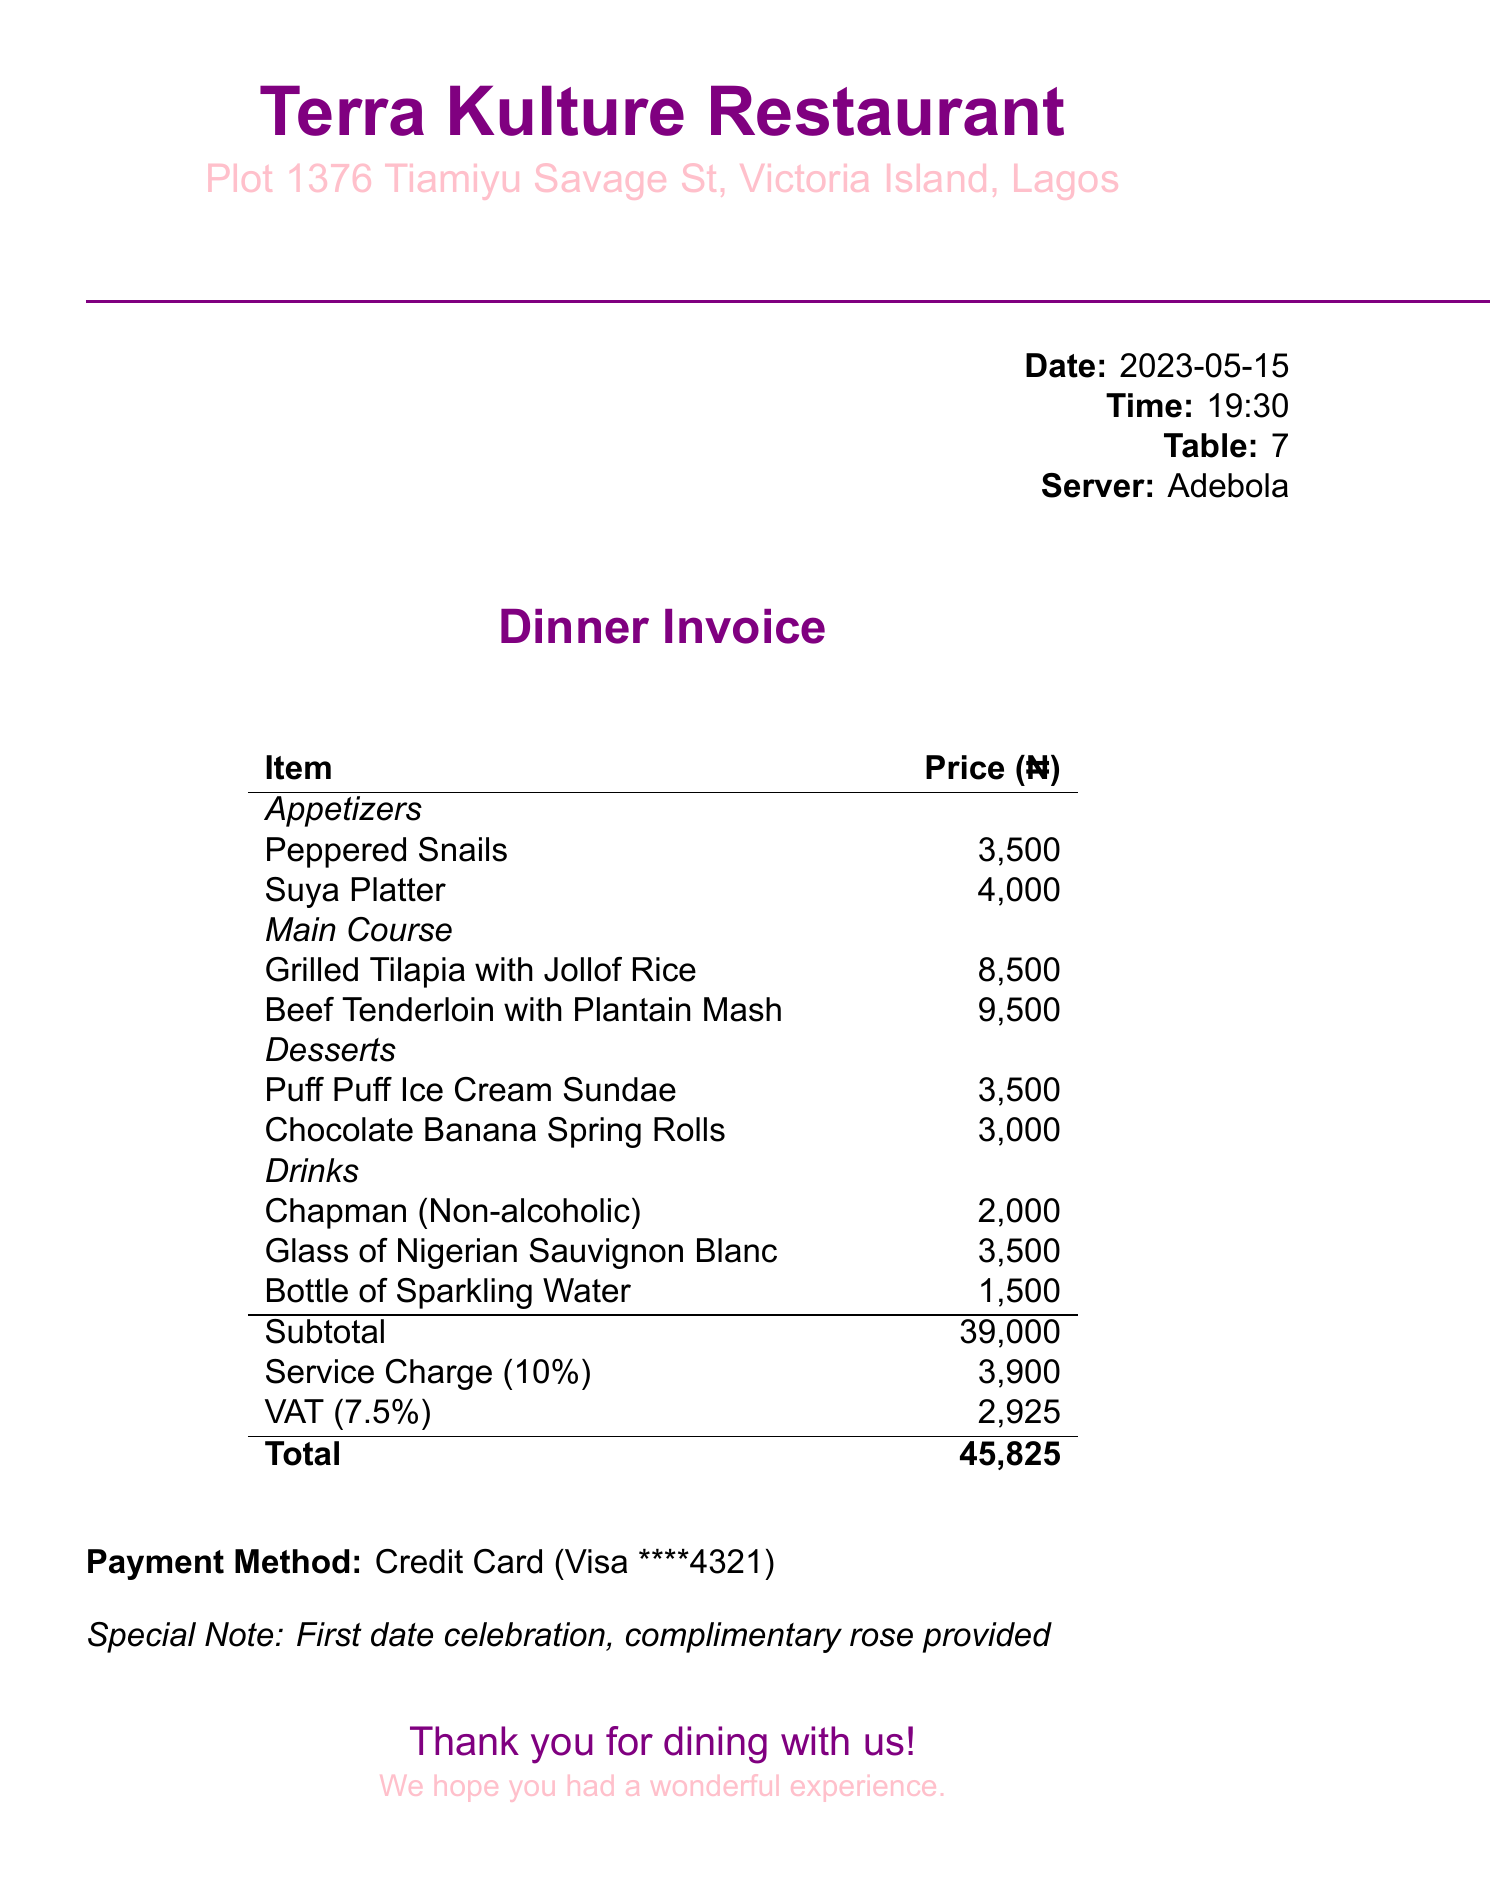what is the name of the restaurant? The name of the restaurant is mentioned at the top of the document.
Answer: Terra Kulture Restaurant what is the date of the dinner? The date of the dinner is listed in the document.
Answer: 2023-05-15 how much is the service charge? The service charge is calculated as a percentage of the subtotal and is specifically mentioned.
Answer: 3,900 who was the server? The server's name is indicated in the document.
Answer: Adebola what was the total amount billed? The total amount is detailed at the bottom of the invoice.
Answer: 45,825 which appetizer had the highest price? The prices of appetizers are listed, and the highest priced one is identifiable.
Answer: Suya Platter how many drinks were ordered? The drinks section lists total drinks ordered, which can be counted.
Answer: 3 what type of card was used for payment? The payment method section specifies the type of card.
Answer: Visa what is the special note on the invoice? The special note is stated at the end of the invoice.
Answer: First date celebration, complimentary rose provided 